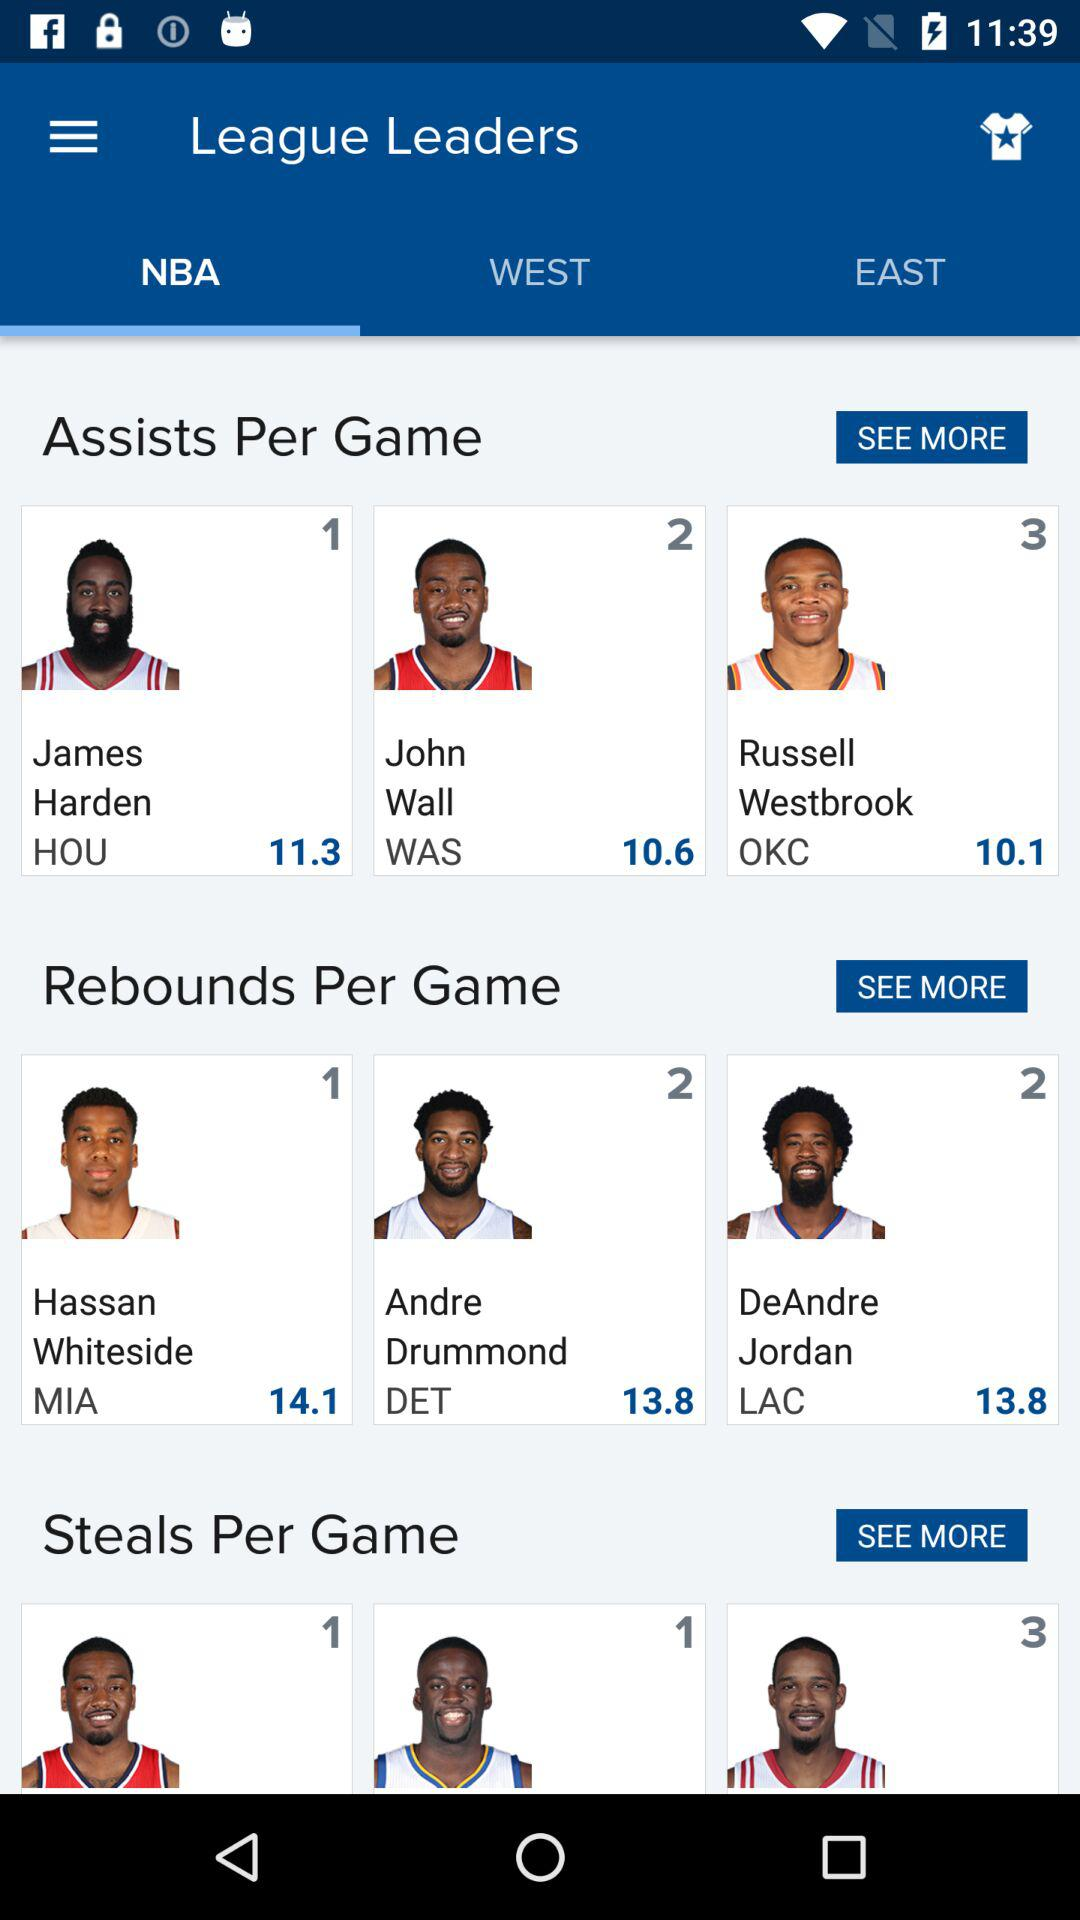What are the player names in "Rebounds Per Game"? The player names in "Rebounds Per Game" are Hassan Whiteside, Andre Drummond and DeAndre Jordan. 